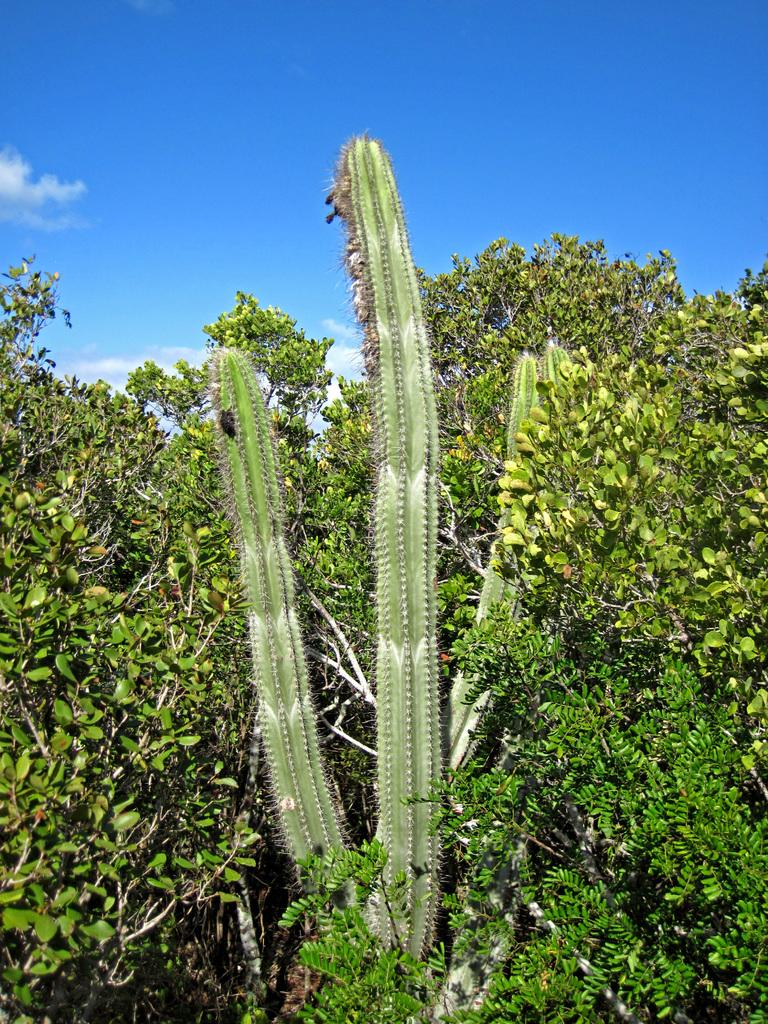What type of living organisms are present in the image? There are plants in the image. What color are the plants in the image? The plants are green in color. What can be seen in the background of the image? The background of the image includes the sky. What colors are visible in the sky in the image? The sky is white and blue in color. What type of canvas is being used for the plant treatment in the image? There is no canvas or plant treatment present in the image; it features plants and the sky. How many toes can be seen on the plants in the image? Plants do not have toes, so this question cannot be answered. 